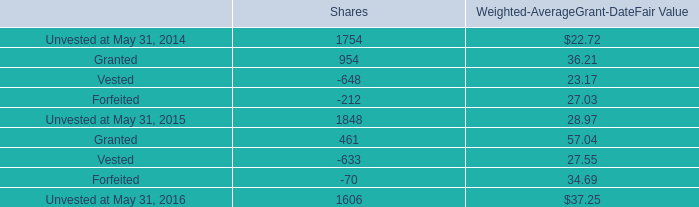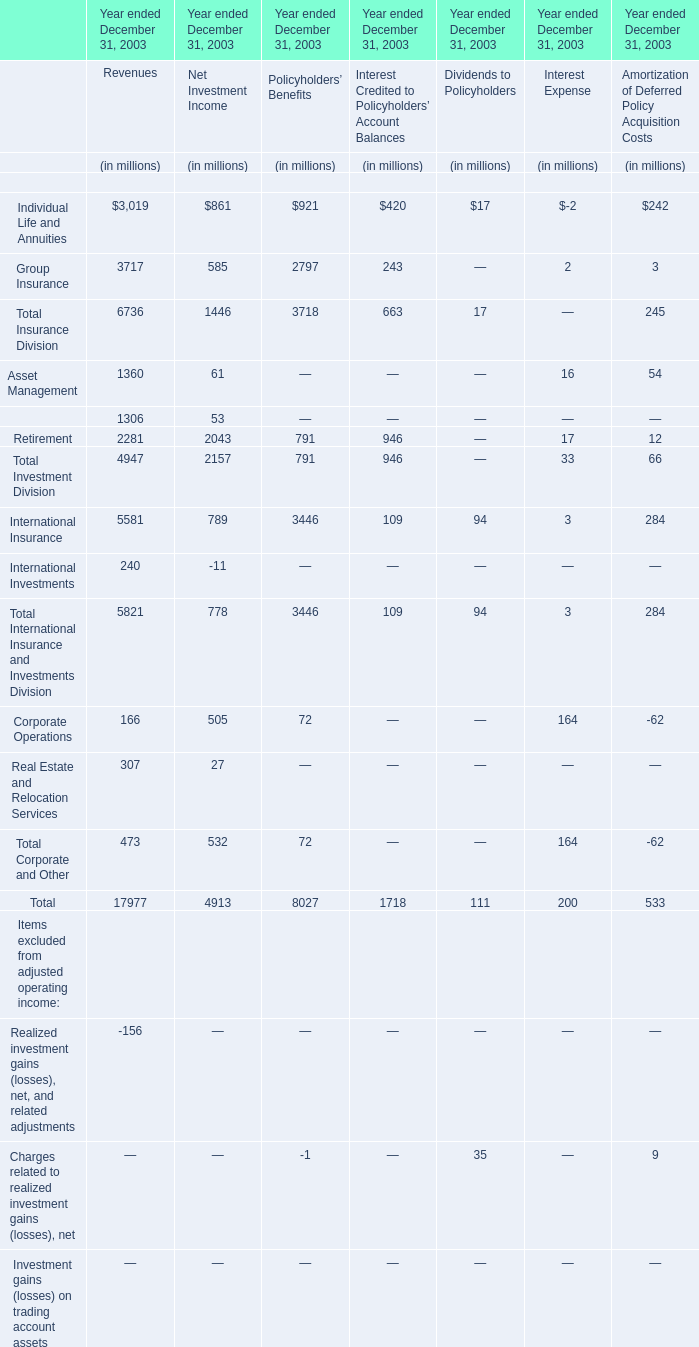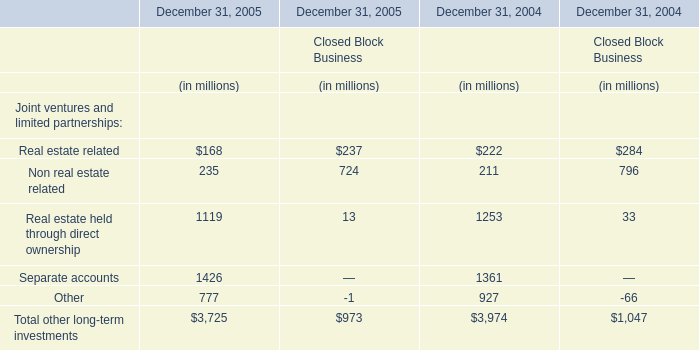Which section is Individual Life and Annuities the highest? 
Answer: Revenues. 